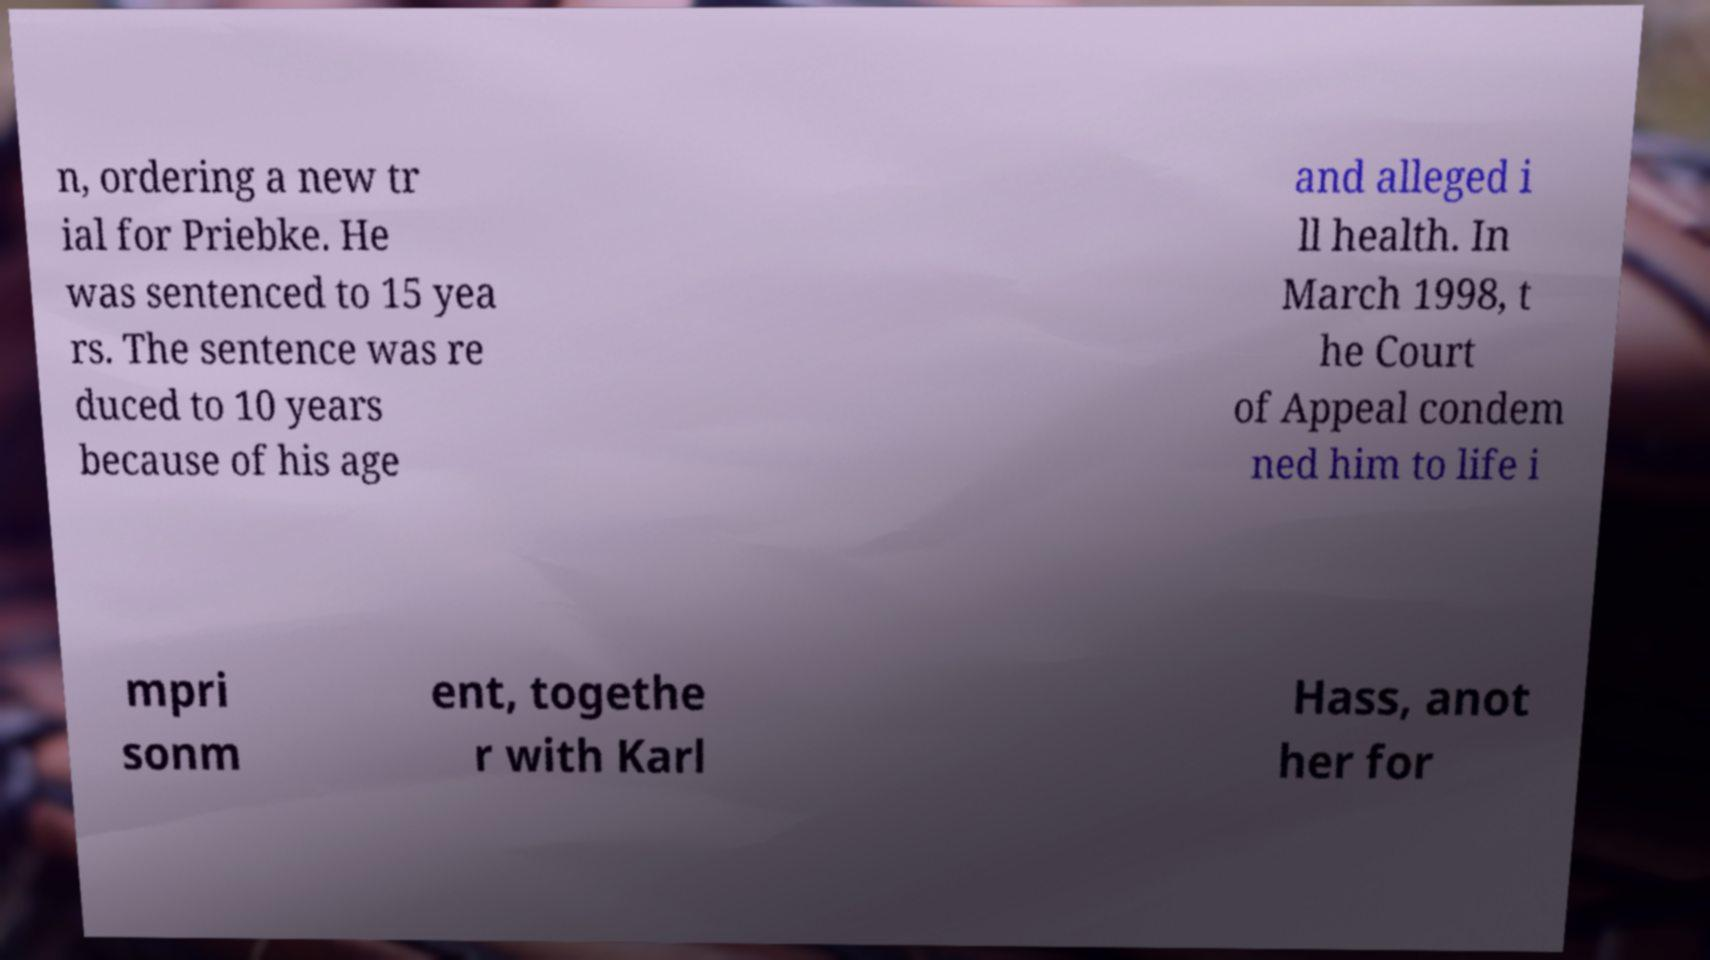What messages or text are displayed in this image? I need them in a readable, typed format. n, ordering a new tr ial for Priebke. He was sentenced to 15 yea rs. The sentence was re duced to 10 years because of his age and alleged i ll health. In March 1998, t he Court of Appeal condem ned him to life i mpri sonm ent, togethe r with Karl Hass, anot her for 